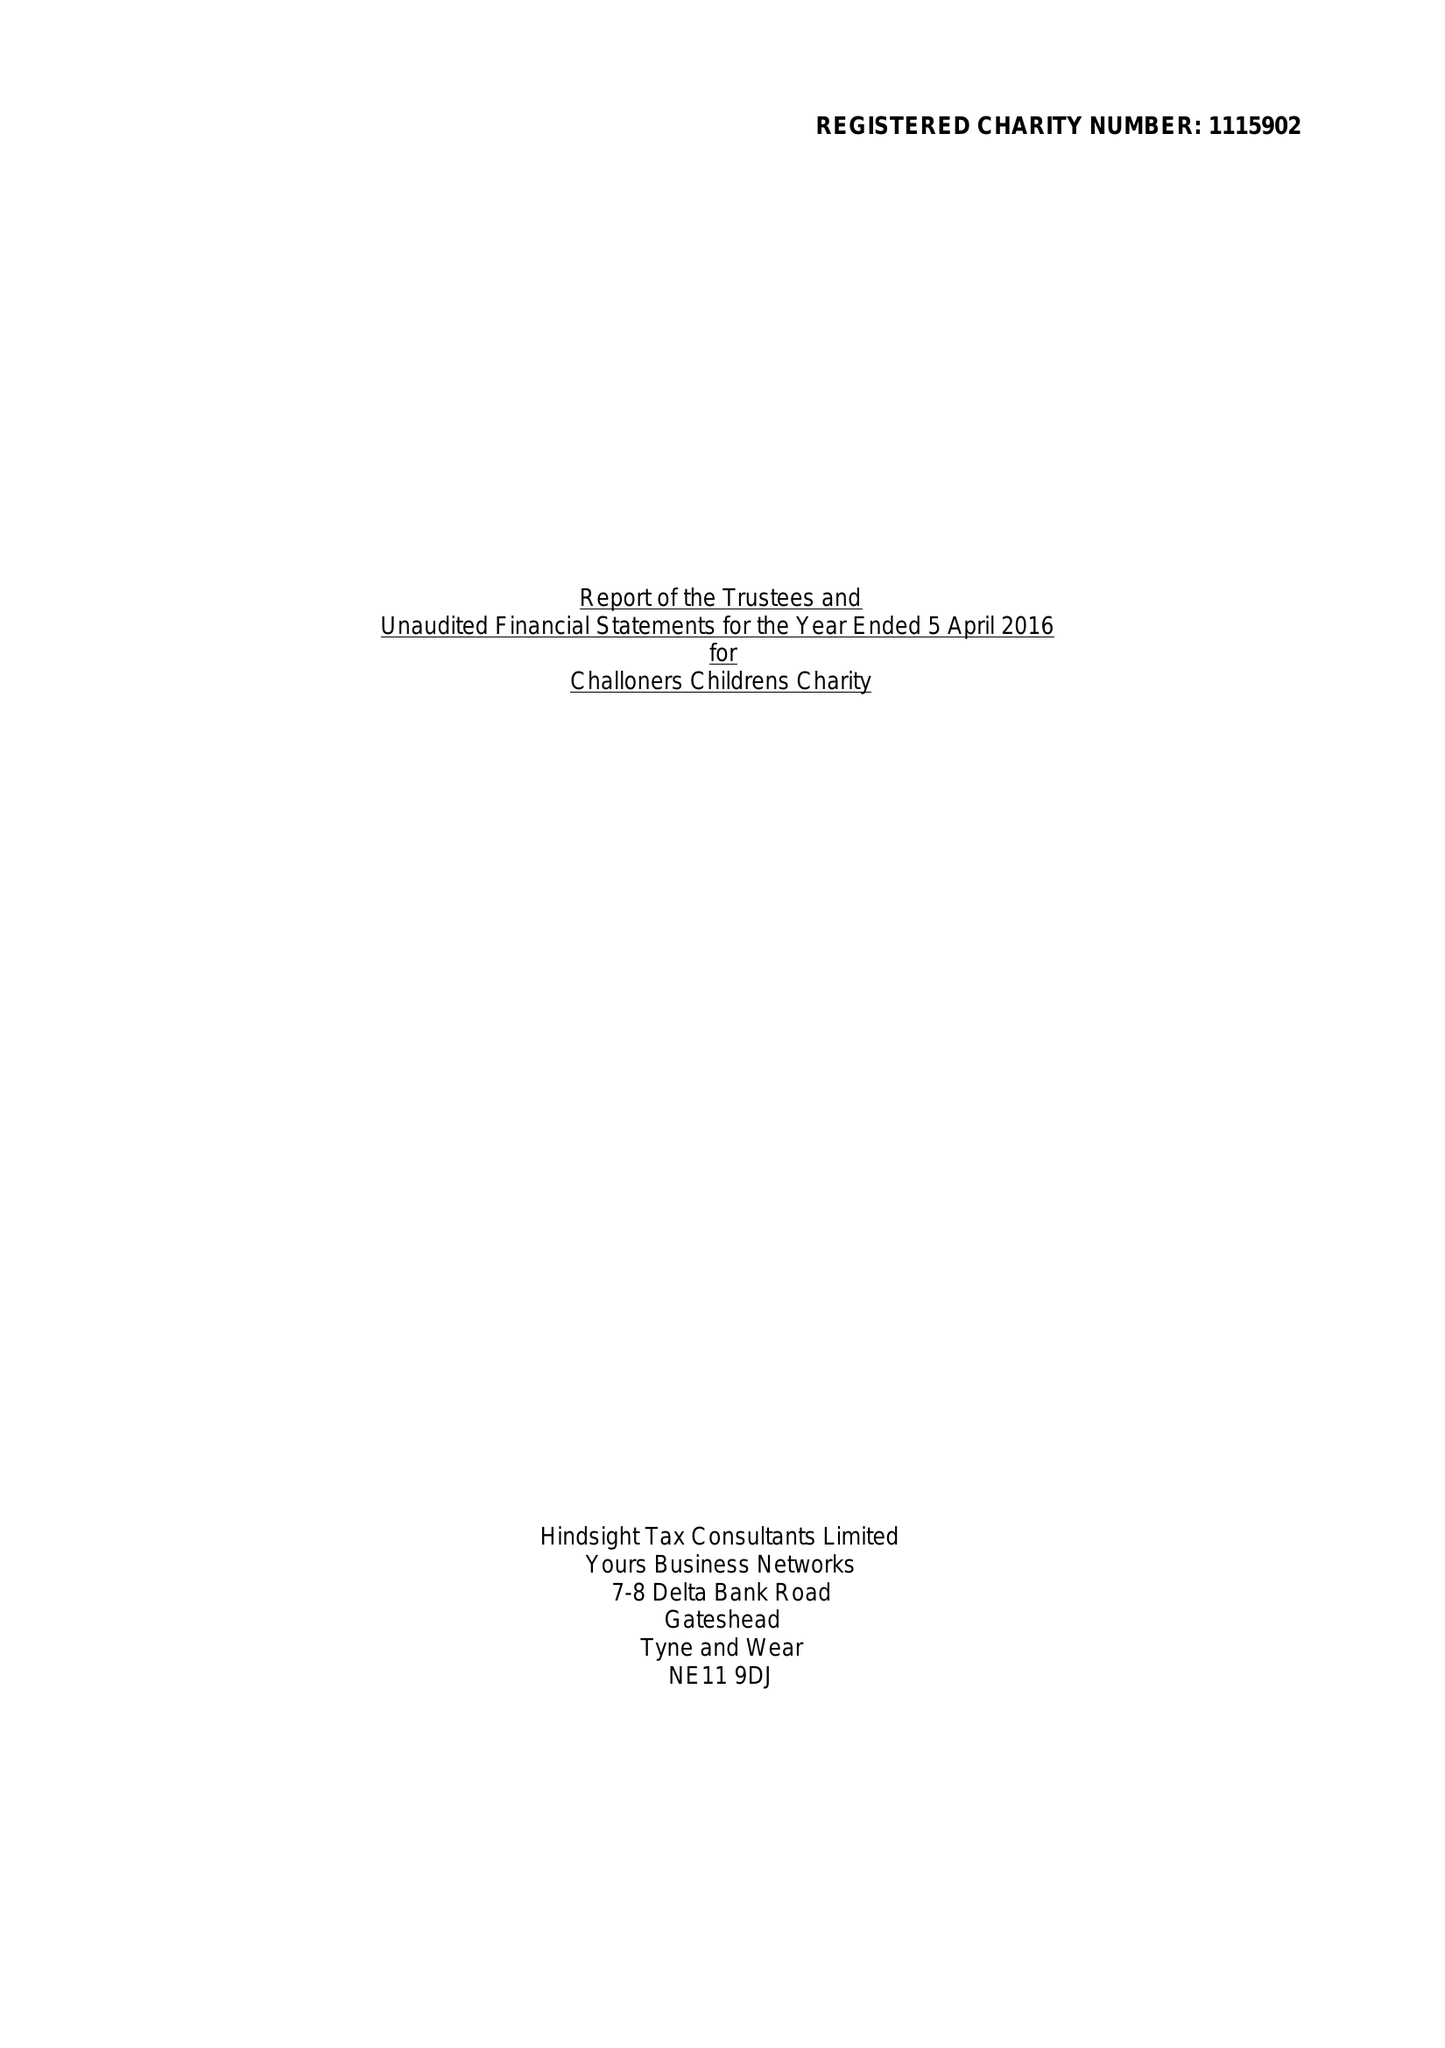What is the value for the address__postcode?
Answer the question using a single word or phrase. SW7 3NX 